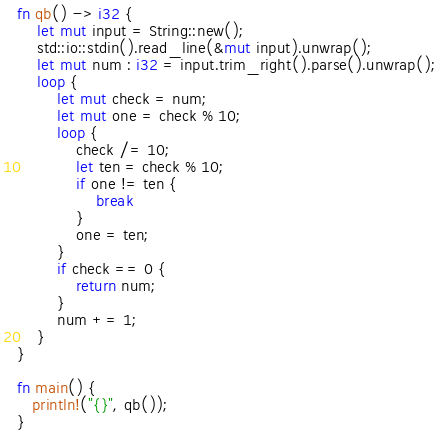<code> <loc_0><loc_0><loc_500><loc_500><_Rust_>fn qb() -> i32 {
    let mut input = String::new();
    std::io::stdin().read_line(&mut input).unwrap();
    let mut num : i32 = input.trim_right().parse().unwrap();
    loop {
        let mut check = num;
        let mut one = check % 10;
        loop {
            check /= 10;
            let ten = check % 10;
            if one != ten {
                break
            }
            one = ten;
        }
        if check == 0 {
            return num;
        }
        num += 1;
    }
}

fn main() {
   println!("{}", qb());
}
</code> 